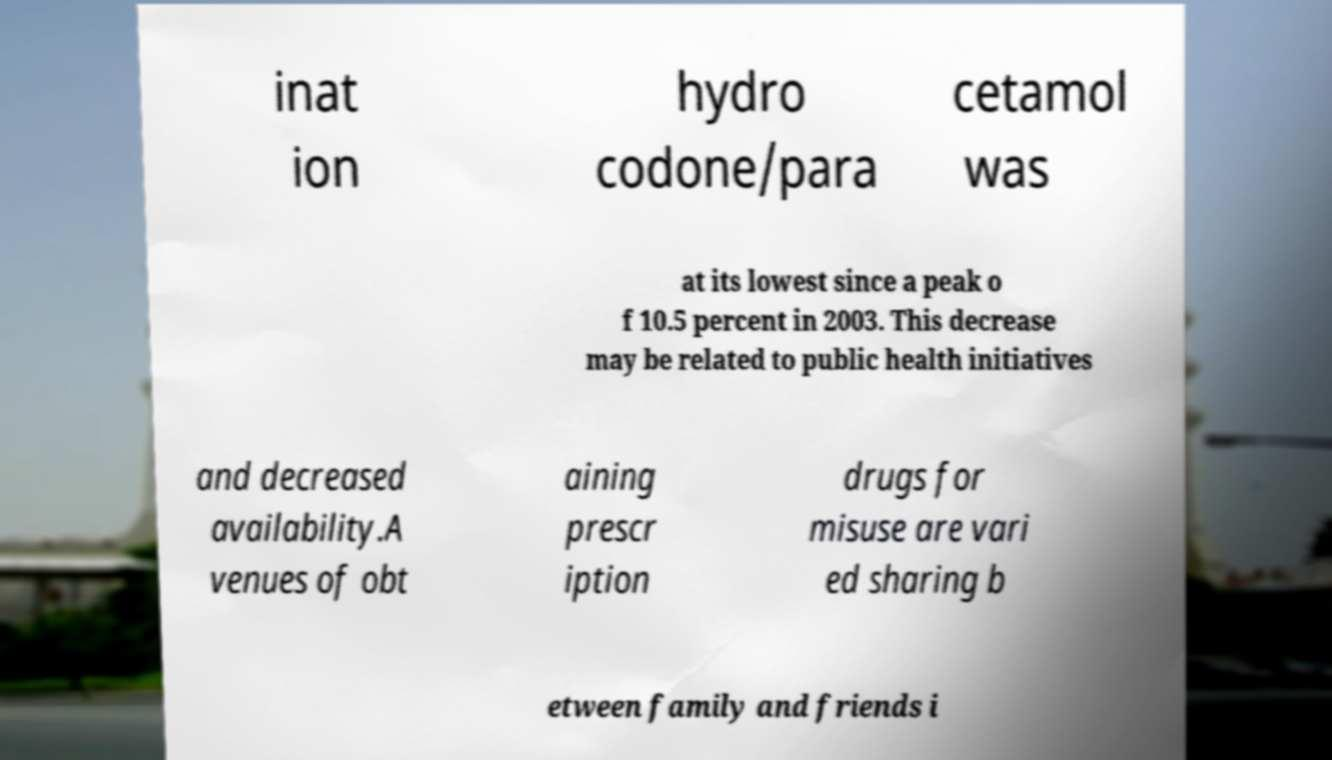What messages or text are displayed in this image? I need them in a readable, typed format. inat ion hydro codone/para cetamol was at its lowest since a peak o f 10.5 percent in 2003. This decrease may be related to public health initiatives and decreased availability.A venues of obt aining prescr iption drugs for misuse are vari ed sharing b etween family and friends i 